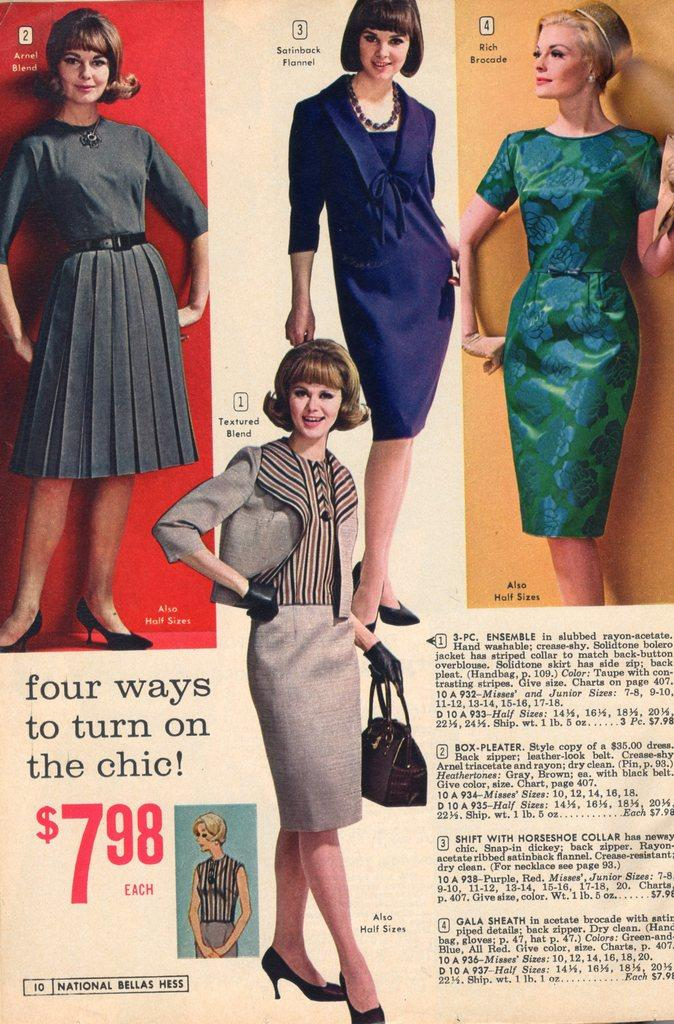What is the main object in the image? There is a newspaper in the image. What can be seen in the newspaper? The newspaper contains images of women. What is the woman in the image holding? A woman is holding a bag in the image. What type of coal is being used to fuel the feast in the image? There is no feast or coal present in the image; it features a newspaper with images of women and a woman holding a bag. 